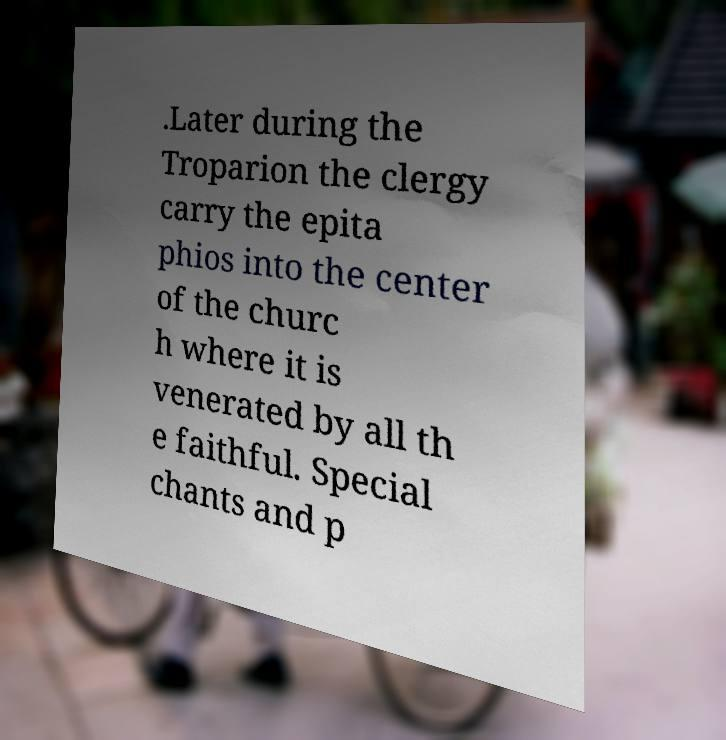I need the written content from this picture converted into text. Can you do that? .Later during the Troparion the clergy carry the epita phios into the center of the churc h where it is venerated by all th e faithful. Special chants and p 